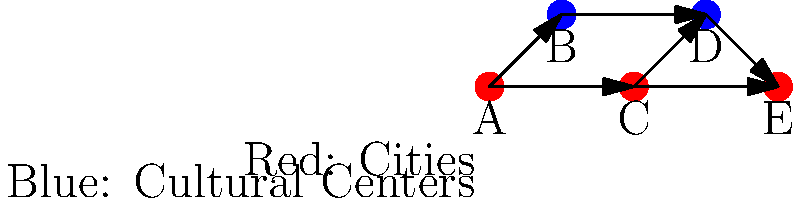In the directed graph representing the flow of information and cultural exchange during the Great Migration, red nodes represent cities and blue nodes represent cultural centers. If information spreads from node to node following the direction of the arrows, what is the minimum number of steps required for information originating in city A to reach city E? To find the minimum number of steps for information to travel from city A to city E, we need to analyze the possible paths:

1. Start at node A (red, representing a city).
2. From A, we have two options:
   a. A → B (cultural center)
   b. A → C (city)
3. Let's explore both paths:
   Path 1: A → B
   - A → B → D → E (3 steps)
   
   Path 2: A → C
   - A → C → D → E (3 steps)
   - A → C → E (2 steps)

4. The shortest path is A → C → E, which takes 2 steps.

Therefore, the minimum number of steps required for information to travel from city A to city E is 2.
Answer: 2 steps 